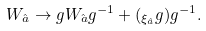Convert formula to latex. <formula><loc_0><loc_0><loc_500><loc_500>W _ { \hat { a } } \to g W _ { \hat { a } } g ^ { - 1 } + ( { \L } _ { \xi _ { \hat { a } } } g ) g ^ { - 1 } .</formula> 